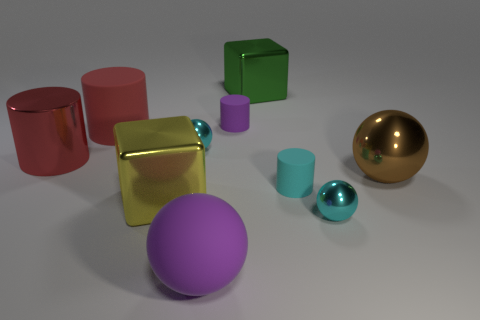Subtract all spheres. How many objects are left? 6 Subtract all metallic cylinders. Subtract all yellow cubes. How many objects are left? 8 Add 3 brown objects. How many brown objects are left? 4 Add 7 big red matte cylinders. How many big red matte cylinders exist? 8 Subtract 0 brown blocks. How many objects are left? 10 